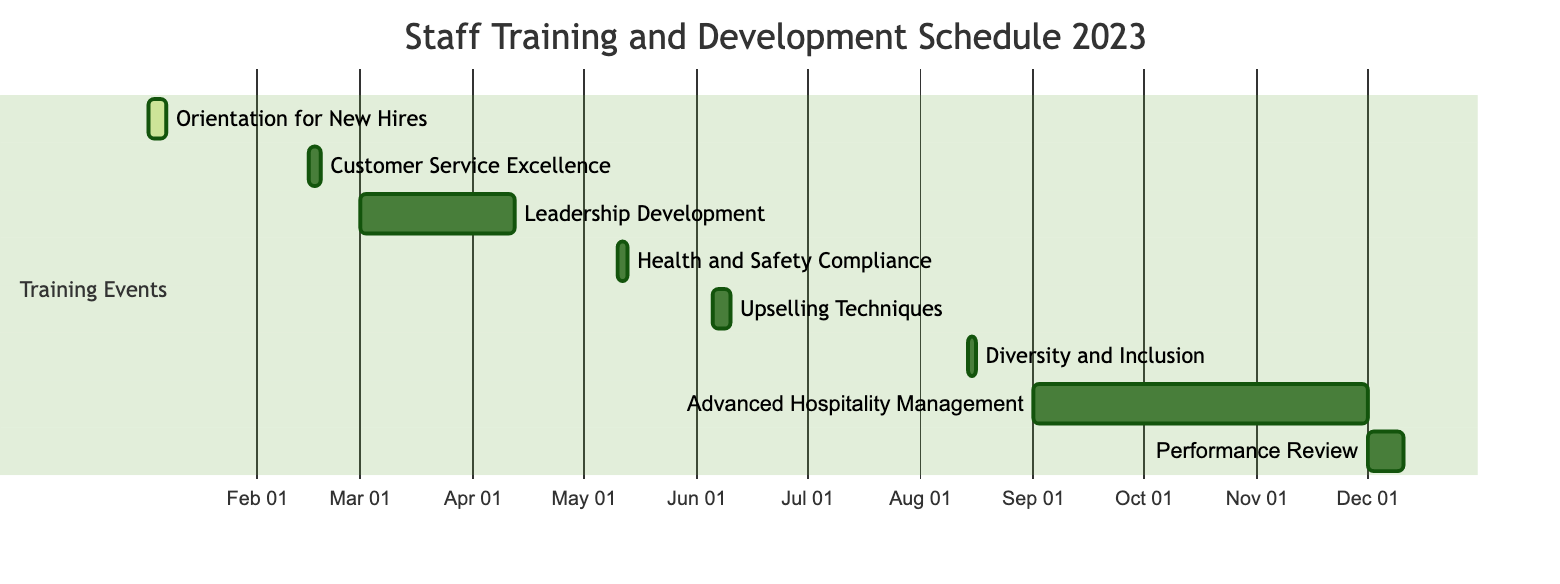What is the duration of the Leadership Development Program? The Leadership Development Program lasts for 6 weeks, as specified in the diagram next to the task.
Answer: 6 weeks What is the start date of the Annual Diversity and Inclusion Workshop? The start date of the Annual Diversity and Inclusion Workshop is indicated in the diagram as August 14, 2023.
Answer: August 14, 2023 How many training events are scheduled before June 2023? By examining the diagram, I count the events: Orientation for New Hires, Customer Service Excellence Workshop, and Leadership Development Program, totaling three events.
Answer: 3 Which training event immediately follows the Health and Safety Compliance Training? The Upselling Techniques Training directly follows the Health and Safety Compliance Training based on their respective end and start dates in the diagram.
Answer: Upselling Techniques Training What is the overall duration of the Advanced Hospitality Management Course? The Advanced Hospitality Management Course is scheduled for 3 months, as stated in the diagram next to the task.
Answer: 3 months How many days is the Performance Review and Feedback Session? The diagram shows that the Performance Review and Feedback Session lasts for 10 days.
Answer: 10 days What is the end date of the Upselling Techniques Training? The end date of the Upselling Techniques Training is June 9, 2023, which is shown next to this task in the diagram.
Answer: June 9, 2023 What is the relationship between the Orientation for New Hires and the Customer Service Excellence Workshop? The Orientation for New Hires is completed before the Customer Service Excellence Workshop begins, indicating a sequential relationship between these two training events.
Answer: Sequential Which training event overlaps with the longest duration? The Advanced Hospitality Management Course overlaps with the longest duration, spanning 3 months from the diagram.
Answer: Advanced Hospitality Management Course 